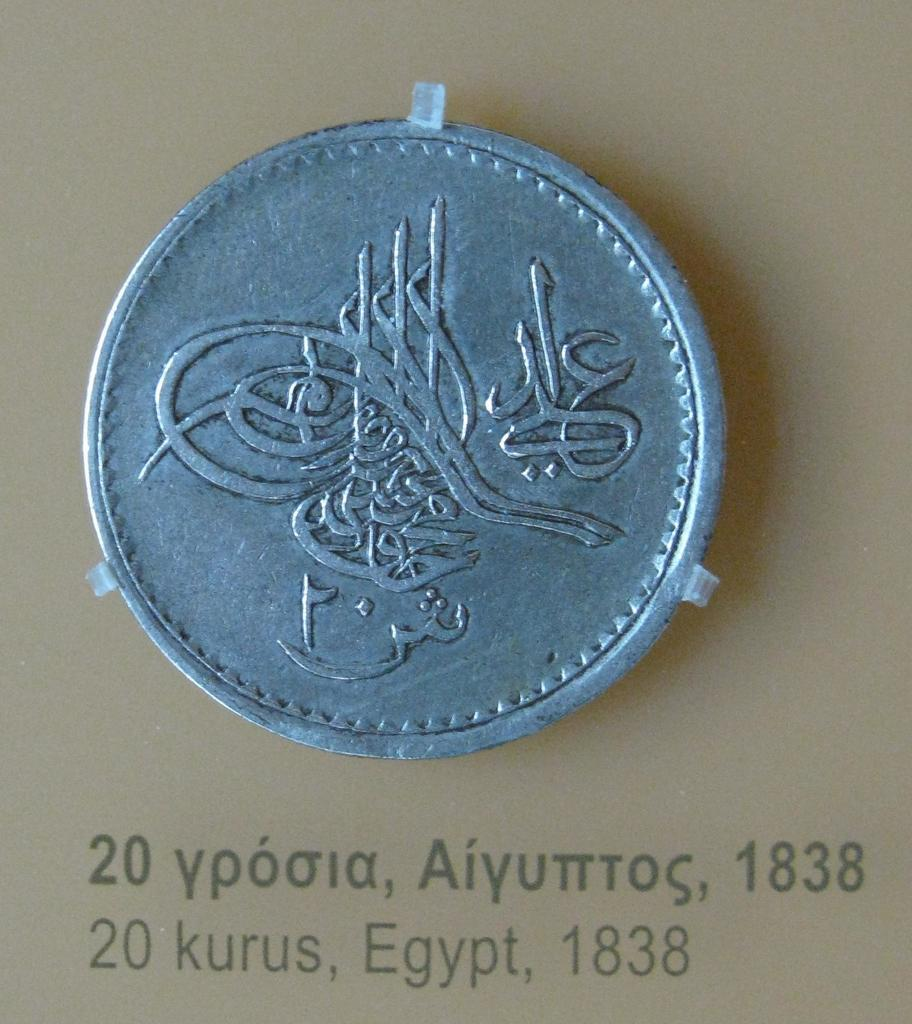<image>
Summarize the visual content of the image. A 20 kurus piece from Egypt, 1838 is displayed. 